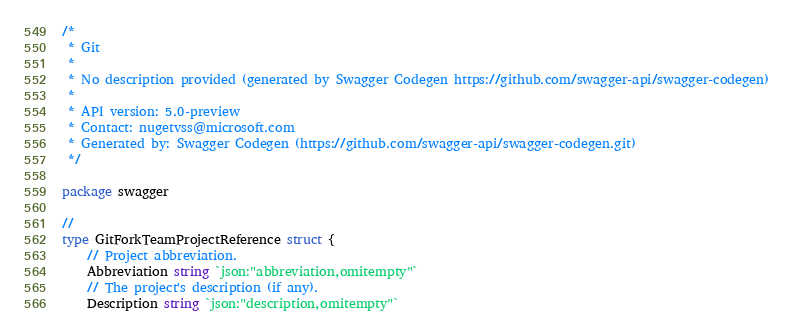Convert code to text. <code><loc_0><loc_0><loc_500><loc_500><_Go_>/*
 * Git
 *
 * No description provided (generated by Swagger Codegen https://github.com/swagger-api/swagger-codegen)
 *
 * API version: 5.0-preview
 * Contact: nugetvss@microsoft.com
 * Generated by: Swagger Codegen (https://github.com/swagger-api/swagger-codegen.git)
 */

package swagger

// 
type GitForkTeamProjectReference struct {
	// Project abbreviation.
	Abbreviation string `json:"abbreviation,omitempty"`
	// The project's description (if any).
	Description string `json:"description,omitempty"`</code> 